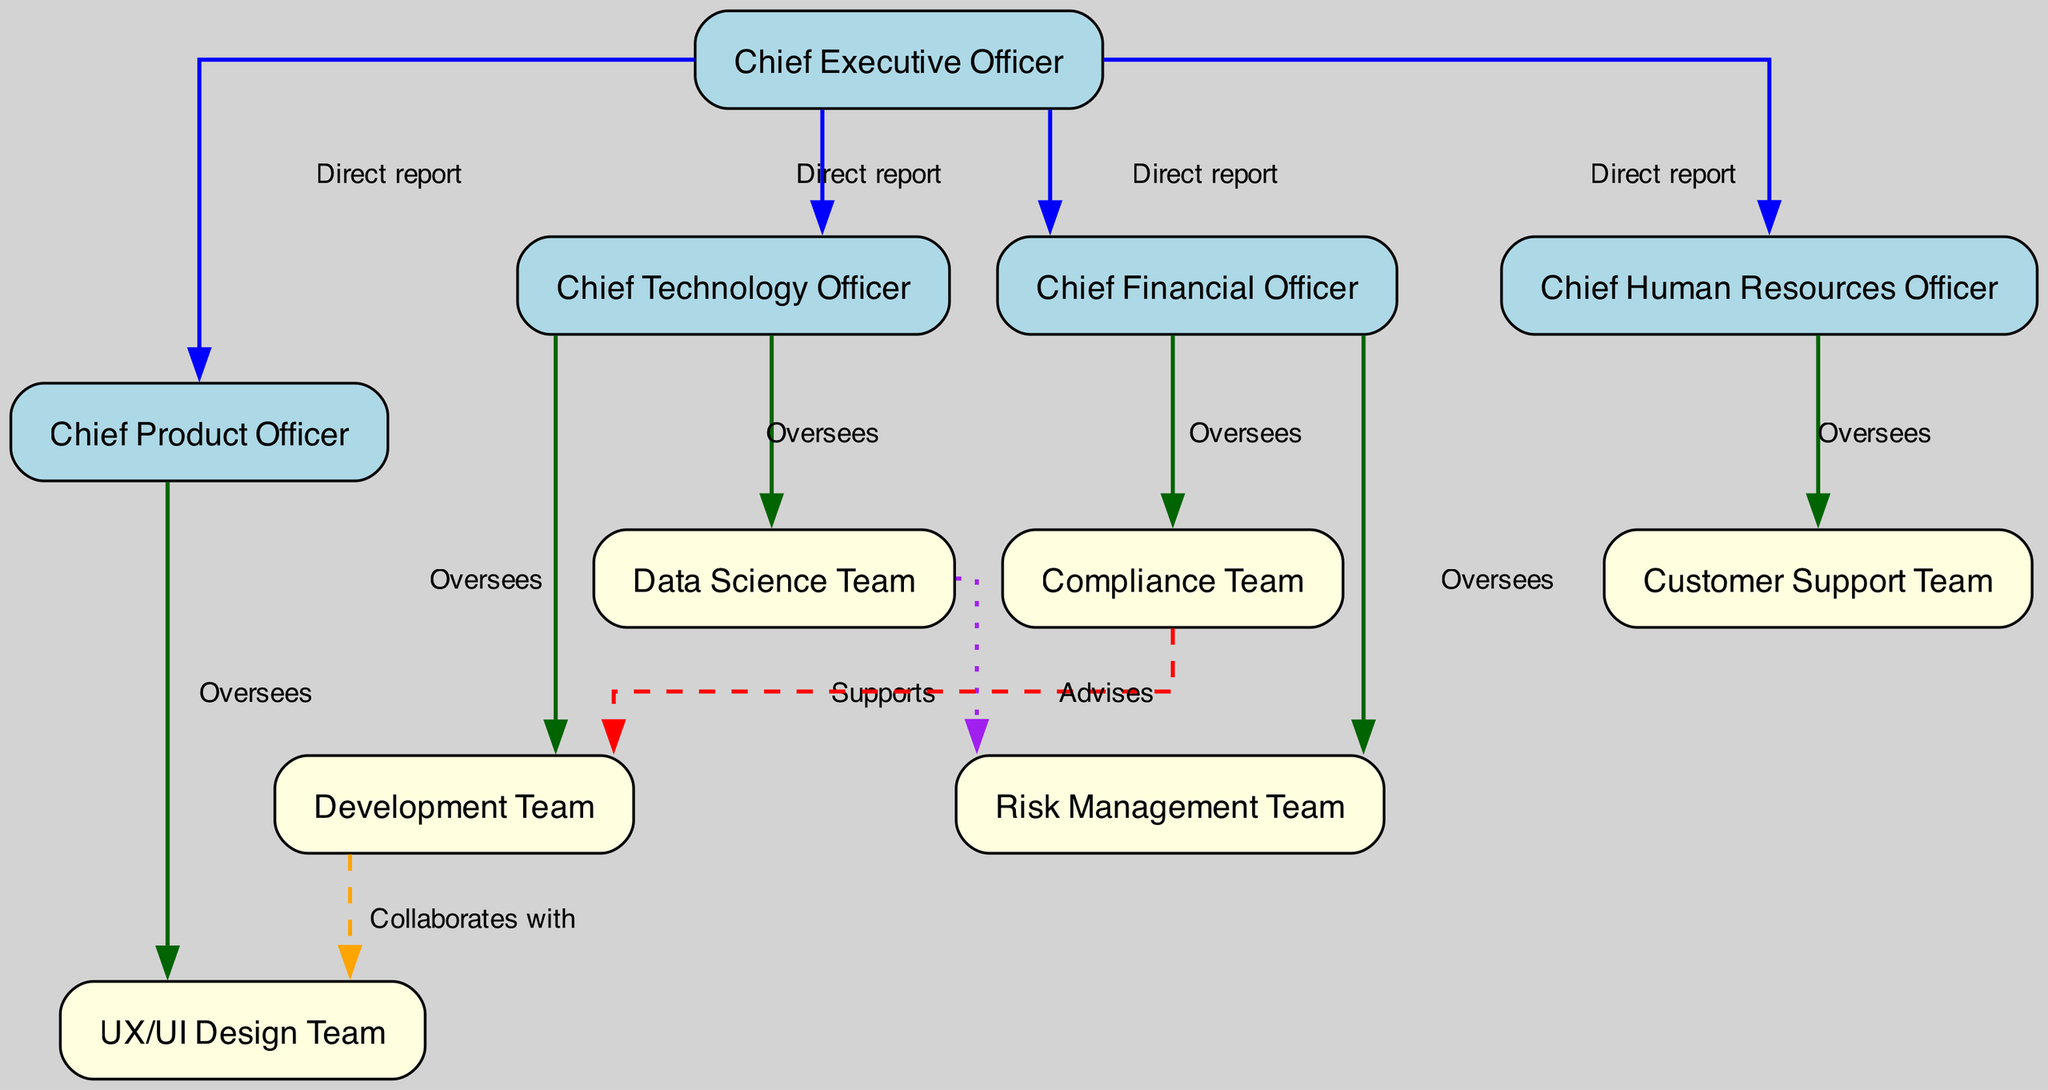What is the highest position in the organizational structure? The diagram indicates that the Chief Executive Officer, or CEO, is at the top of the hierarchical structure, making it the highest position.
Answer: Chief Executive Officer How many direct reports does the CEO have? By analyzing the edges originating from the CEO in the diagram, we find four direct reports: CTO, CFO, CPO, and CHRO, which totals to four direct reports.
Answer: Four Which team does the Chief Technology Officer oversee? The diagram shows two teams that the CTO oversees: the Development Team and the Data Science Team, both connected by an "Oversees" edge.
Answer: Development Team, Data Science Team What type of relationship exists between the Development Team and the UX/UI Design Team? The relationship is labeled as "Collaborates with" in the diagram, indicating a collaborative interaction between the two teams.
Answer: Collaborates with Who does the Compliance Team advise? According to the diagram, the Compliance Team advises the Development Team, which is indicated by the "Advises" edge connecting them.
Answer: Development Team Which roles oversee risk-related teams? The diagram reveals that the Chief Financial Officer oversees both the Risk Management Team and the Compliance Team, as shown by the "Oversees" label connecting them.
Answer: Chief Financial Officer How is the Data Science Team related to the Risk Management Team? The diagram indicates that the Data Science Team supports the Risk Management Team through a "Supports" relationship, illustrating that the Data Science Team provides assistance.
Answer: Supports How many teams report to the Chief Product Officer? The Chief Product Officer oversees only one team, which is the UX/UI Design Team, as indicated by the single "Oversees" edge.
Answer: One What is the nature of the relationship between the Data Science Team and the Risk Management Team? The diagram indicates that the relationship is one of "Supports," meaning the Data Science Team provides support to the Risk Management Team.
Answer: Supports 